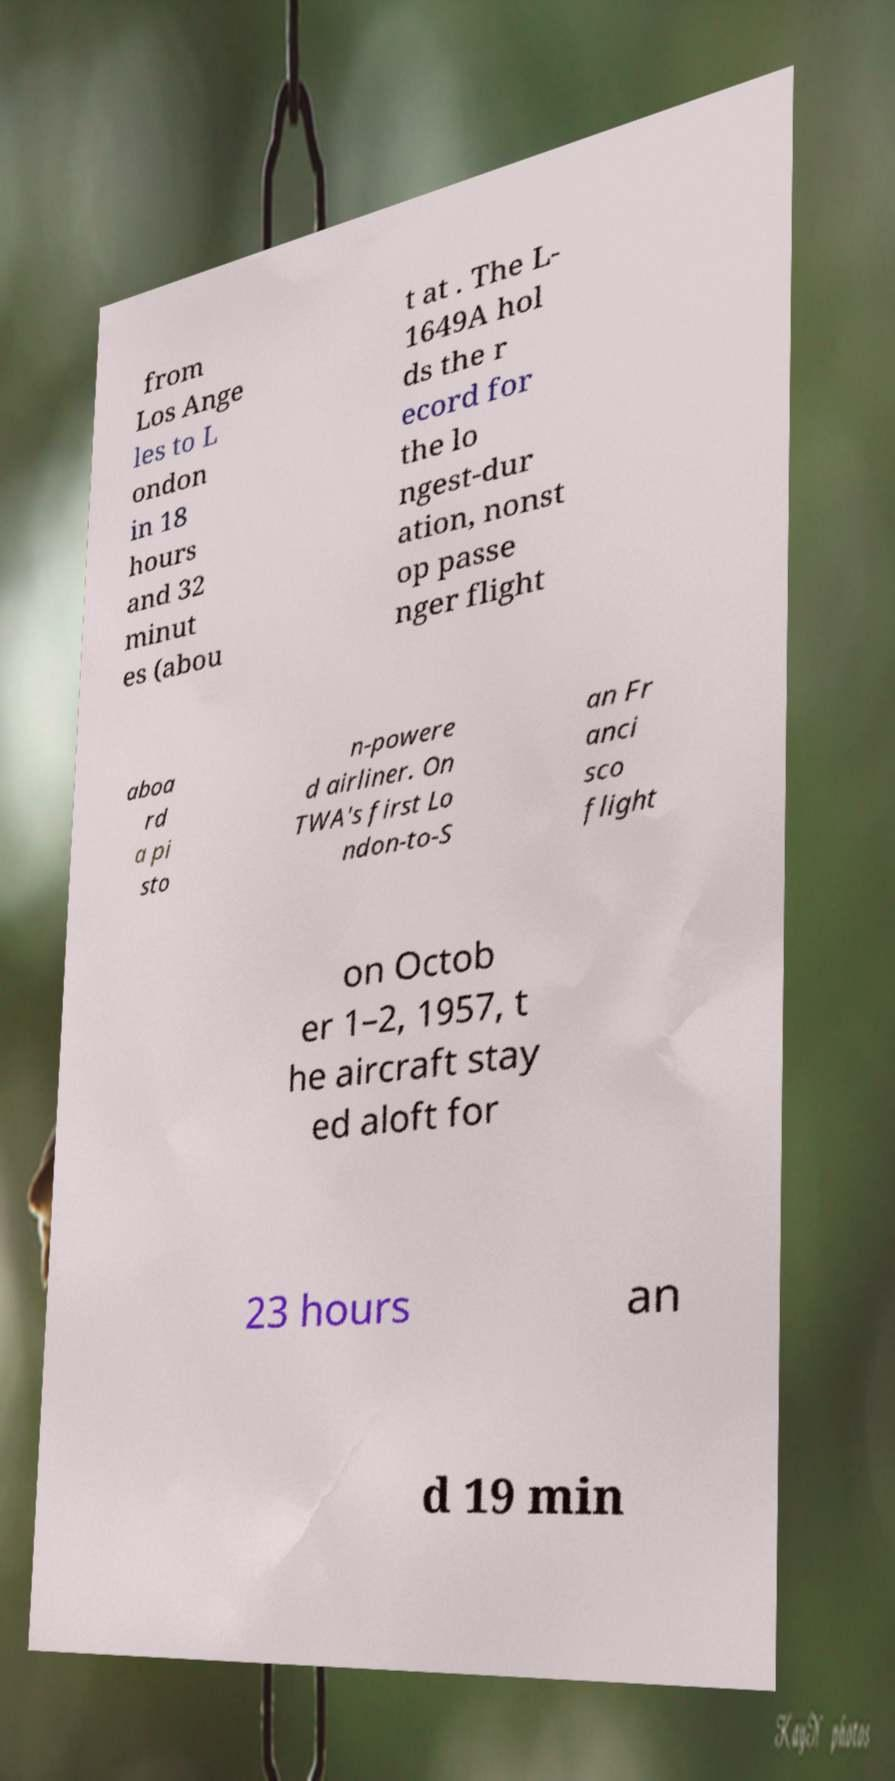Please identify and transcribe the text found in this image. from Los Ange les to L ondon in 18 hours and 32 minut es (abou t at . The L- 1649A hol ds the r ecord for the lo ngest-dur ation, nonst op passe nger flight aboa rd a pi sto n-powere d airliner. On TWA's first Lo ndon-to-S an Fr anci sco flight on Octob er 1–2, 1957, t he aircraft stay ed aloft for 23 hours an d 19 min 